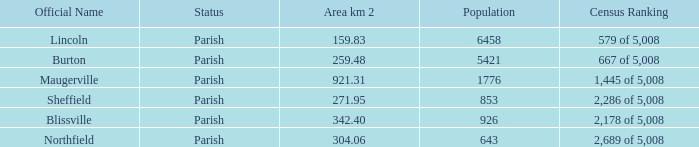06 km2? Northfield. 